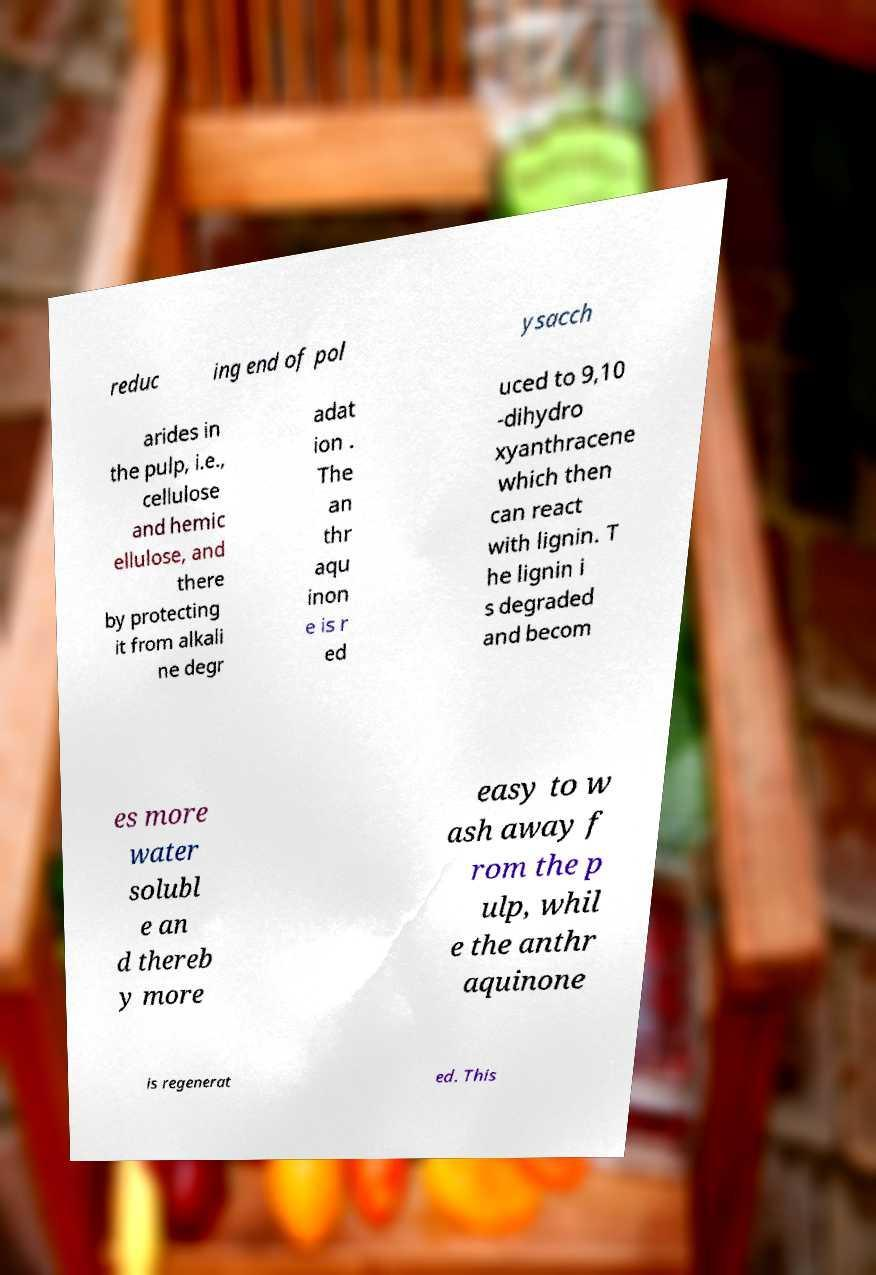What messages or text are displayed in this image? I need them in a readable, typed format. reduc ing end of pol ysacch arides in the pulp, i.e., cellulose and hemic ellulose, and there by protecting it from alkali ne degr adat ion . The an thr aqu inon e is r ed uced to 9,10 -dihydro xyanthracene which then can react with lignin. T he lignin i s degraded and becom es more water solubl e an d thereb y more easy to w ash away f rom the p ulp, whil e the anthr aquinone is regenerat ed. This 